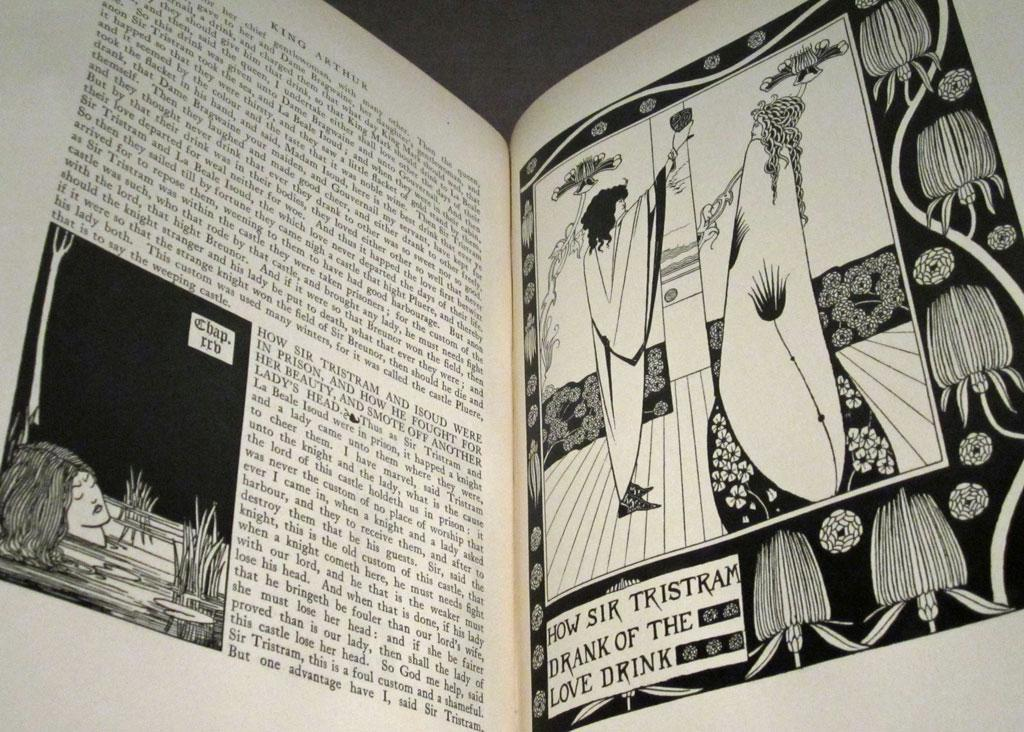<image>
Give a short and clear explanation of the subsequent image. The King Arthur book opened to the section on How Sir Tristram drank of the love drink. 